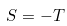<formula> <loc_0><loc_0><loc_500><loc_500>S = - T</formula> 